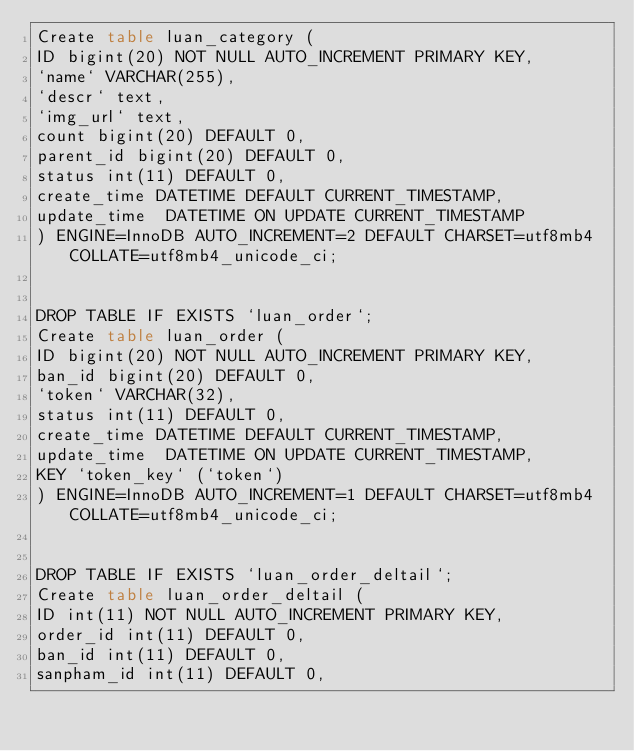Convert code to text. <code><loc_0><loc_0><loc_500><loc_500><_SQL_>Create table luan_category (
ID bigint(20) NOT NULL AUTO_INCREMENT PRIMARY KEY,
`name` VARCHAR(255),
`descr` text,
`img_url` text,
count bigint(20) DEFAULT 0,
parent_id bigint(20) DEFAULT 0,
status int(11) DEFAULT 0,
create_time DATETIME DEFAULT CURRENT_TIMESTAMP,
update_time  DATETIME ON UPDATE CURRENT_TIMESTAMP
) ENGINE=InnoDB AUTO_INCREMENT=2 DEFAULT CHARSET=utf8mb4 COLLATE=utf8mb4_unicode_ci;


DROP TABLE IF EXISTS `luan_order`;
Create table luan_order (
ID bigint(20) NOT NULL AUTO_INCREMENT PRIMARY KEY,
ban_id bigint(20) DEFAULT 0,
`token` VARCHAR(32),
status int(11) DEFAULT 0,
create_time DATETIME DEFAULT CURRENT_TIMESTAMP,
update_time  DATETIME ON UPDATE CURRENT_TIMESTAMP,
KEY `token_key` (`token`)
) ENGINE=InnoDB AUTO_INCREMENT=1 DEFAULT CHARSET=utf8mb4 COLLATE=utf8mb4_unicode_ci;


DROP TABLE IF EXISTS `luan_order_deltail`;
Create table luan_order_deltail (
ID int(11) NOT NULL AUTO_INCREMENT PRIMARY KEY,
order_id int(11) DEFAULT 0,
ban_id int(11) DEFAULT 0,
sanpham_id int(11) DEFAULT 0,</code> 